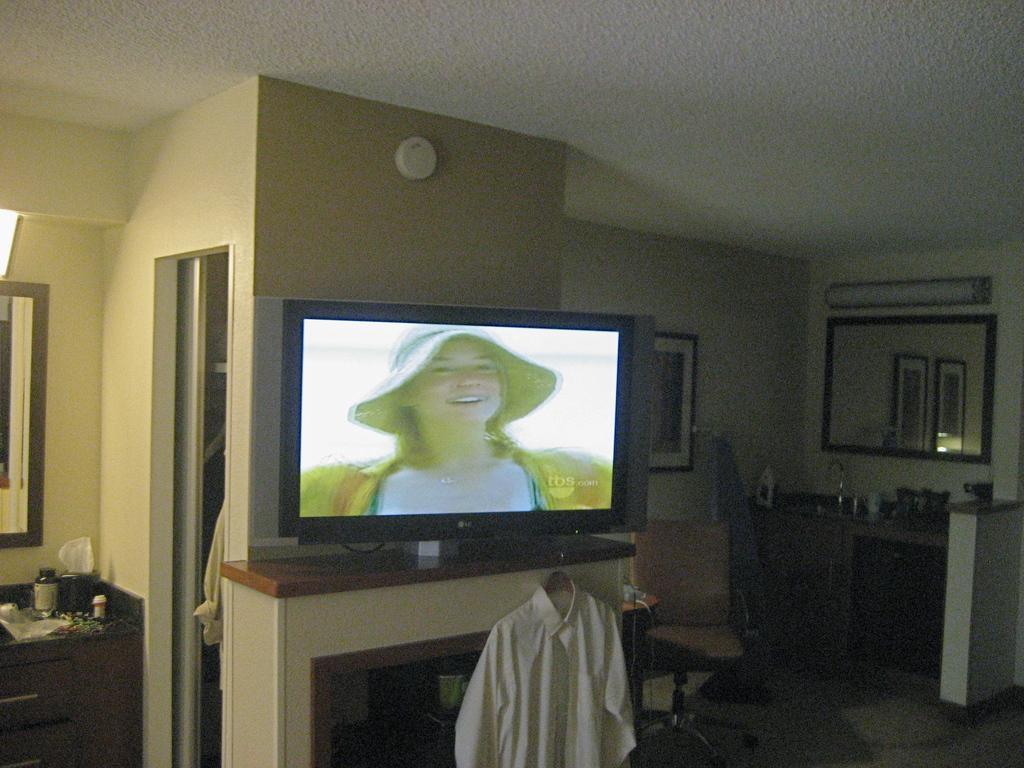In one or two sentences, can you explain what this image depicts? As we can see in the image there is a wall, photo frame, mirror, lights, window, television, cloth and table. 